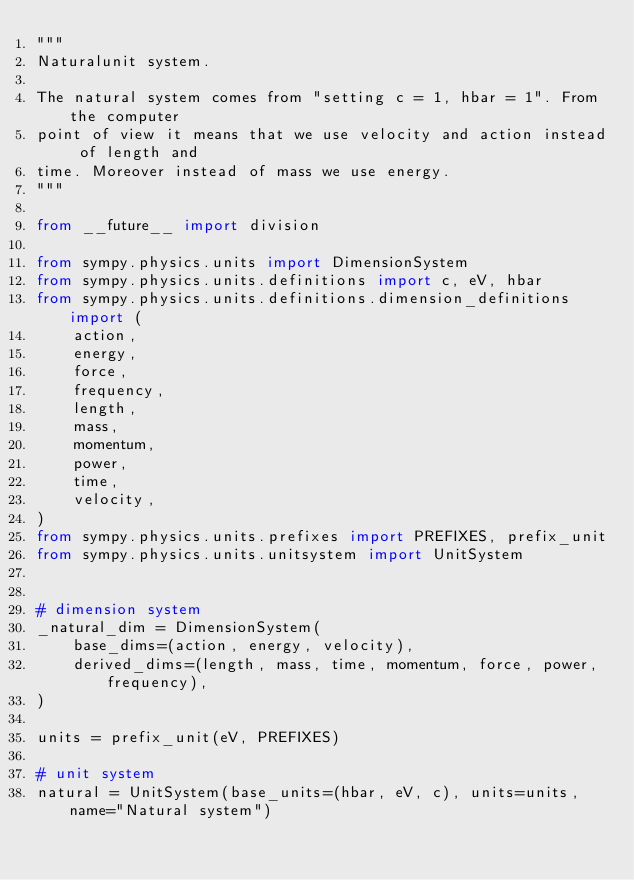Convert code to text. <code><loc_0><loc_0><loc_500><loc_500><_Python_>"""
Naturalunit system.

The natural system comes from "setting c = 1, hbar = 1". From the computer
point of view it means that we use velocity and action instead of length and
time. Moreover instead of mass we use energy.
"""

from __future__ import division

from sympy.physics.units import DimensionSystem
from sympy.physics.units.definitions import c, eV, hbar
from sympy.physics.units.definitions.dimension_definitions import (
    action,
    energy,
    force,
    frequency,
    length,
    mass,
    momentum,
    power,
    time,
    velocity,
)
from sympy.physics.units.prefixes import PREFIXES, prefix_unit
from sympy.physics.units.unitsystem import UnitSystem


# dimension system
_natural_dim = DimensionSystem(
    base_dims=(action, energy, velocity),
    derived_dims=(length, mass, time, momentum, force, power, frequency),
)

units = prefix_unit(eV, PREFIXES)

# unit system
natural = UnitSystem(base_units=(hbar, eV, c), units=units, name="Natural system")
</code> 